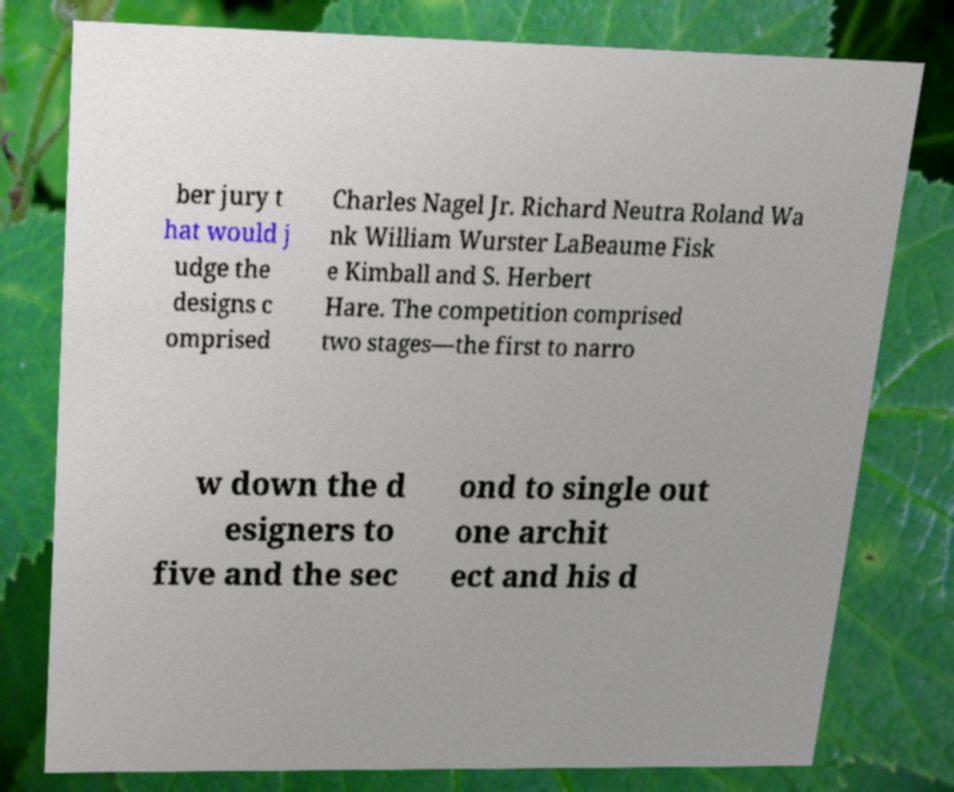Could you assist in decoding the text presented in this image and type it out clearly? ber jury t hat would j udge the designs c omprised Charles Nagel Jr. Richard Neutra Roland Wa nk William Wurster LaBeaume Fisk e Kimball and S. Herbert Hare. The competition comprised two stages—the first to narro w down the d esigners to five and the sec ond to single out one archit ect and his d 